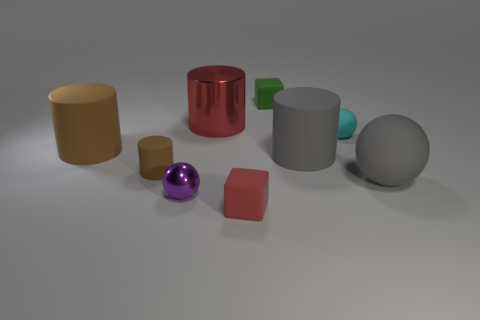Add 1 tiny matte cubes. How many objects exist? 10 Subtract all small rubber cylinders. How many cylinders are left? 3 Subtract all gray spheres. How many spheres are left? 2 Subtract all matte blocks. Subtract all gray matte cylinders. How many objects are left? 6 Add 1 gray cylinders. How many gray cylinders are left? 2 Add 4 green matte cubes. How many green matte cubes exist? 5 Subtract 0 gray blocks. How many objects are left? 9 Subtract all cubes. How many objects are left? 7 Subtract 1 cylinders. How many cylinders are left? 3 Subtract all yellow cylinders. Subtract all green blocks. How many cylinders are left? 4 